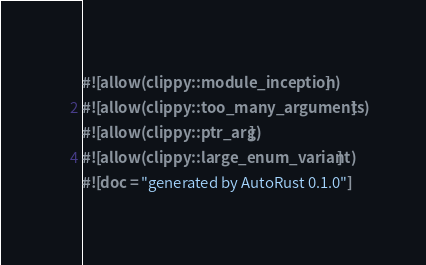Convert code to text. <code><loc_0><loc_0><loc_500><loc_500><_Rust_>#![allow(clippy::module_inception)]
#![allow(clippy::too_many_arguments)]
#![allow(clippy::ptr_arg)]
#![allow(clippy::large_enum_variant)]
#![doc = "generated by AutoRust 0.1.0"]</code> 